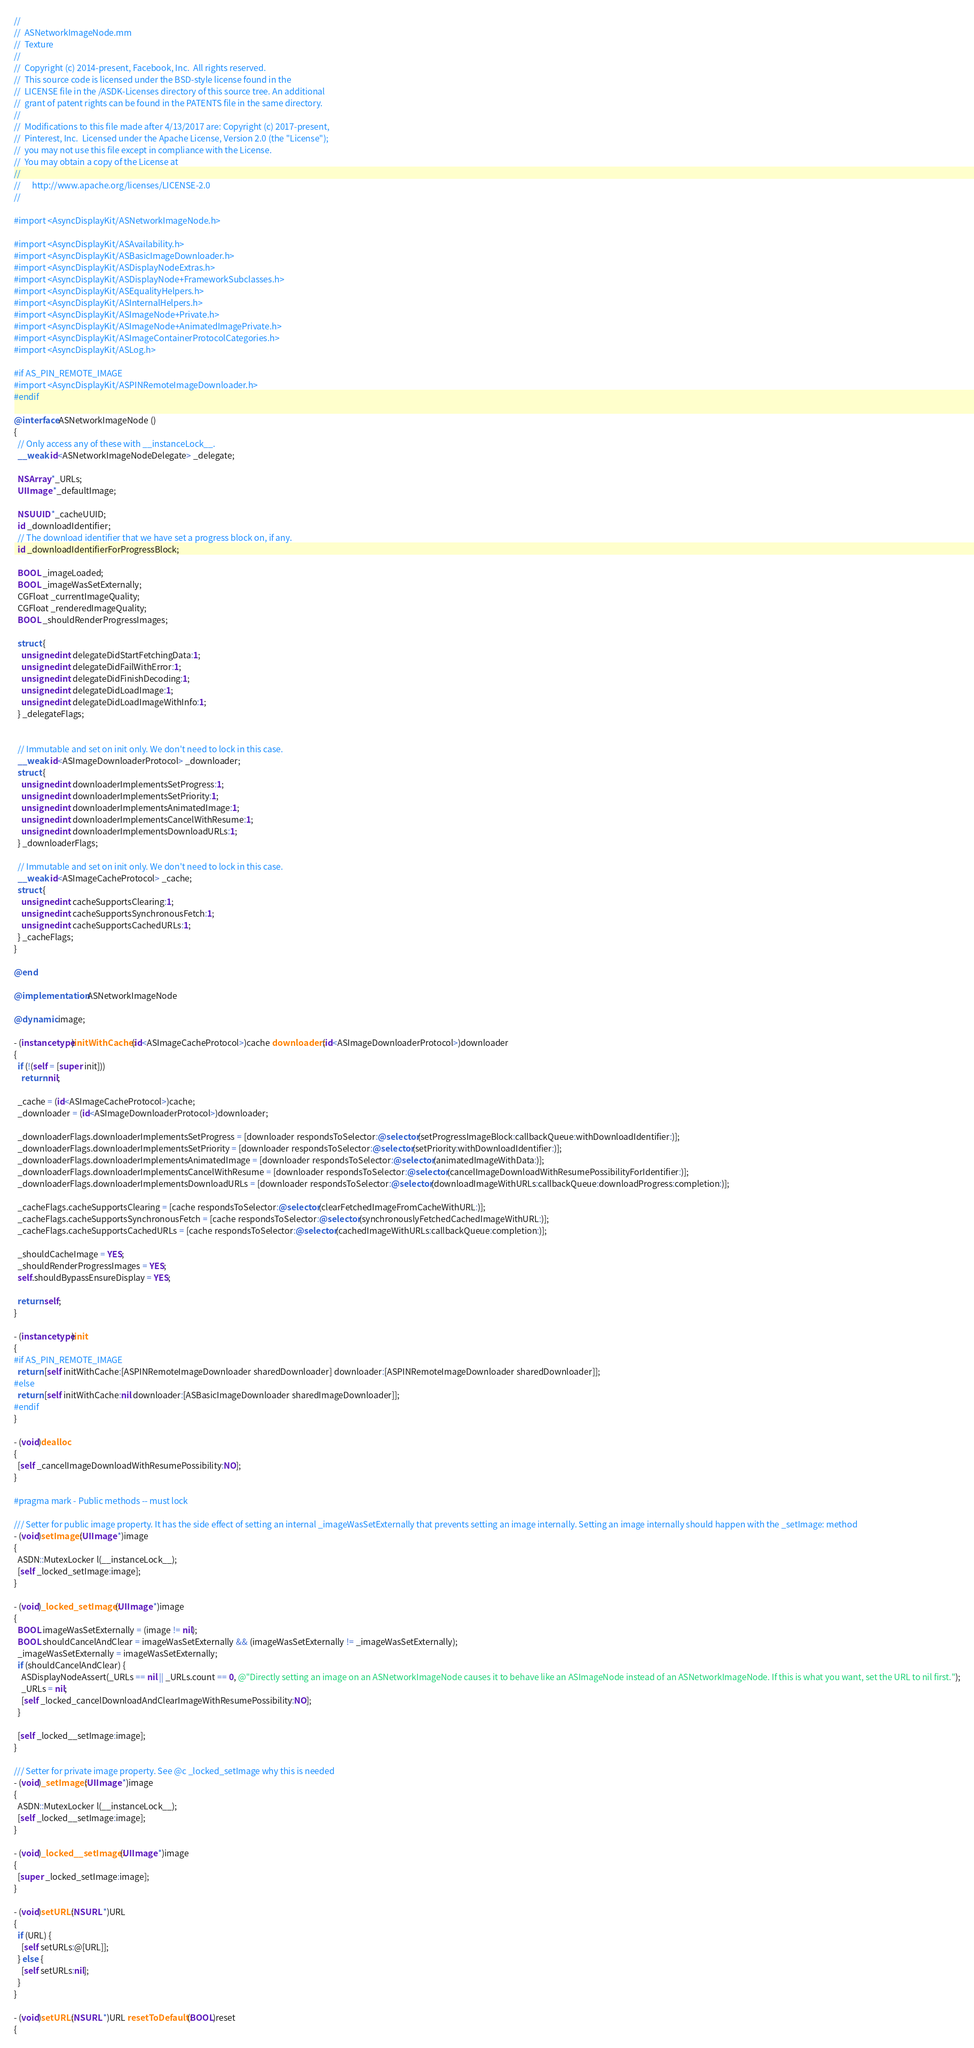Convert code to text. <code><loc_0><loc_0><loc_500><loc_500><_ObjectiveC_>//
//  ASNetworkImageNode.mm
//  Texture
//
//  Copyright (c) 2014-present, Facebook, Inc.  All rights reserved.
//  This source code is licensed under the BSD-style license found in the
//  LICENSE file in the /ASDK-Licenses directory of this source tree. An additional
//  grant of patent rights can be found in the PATENTS file in the same directory.
//
//  Modifications to this file made after 4/13/2017 are: Copyright (c) 2017-present,
//  Pinterest, Inc.  Licensed under the Apache License, Version 2.0 (the "License");
//  you may not use this file except in compliance with the License.
//  You may obtain a copy of the License at
//
//      http://www.apache.org/licenses/LICENSE-2.0
//

#import <AsyncDisplayKit/ASNetworkImageNode.h>

#import <AsyncDisplayKit/ASAvailability.h>
#import <AsyncDisplayKit/ASBasicImageDownloader.h>
#import <AsyncDisplayKit/ASDisplayNodeExtras.h>
#import <AsyncDisplayKit/ASDisplayNode+FrameworkSubclasses.h>
#import <AsyncDisplayKit/ASEqualityHelpers.h>
#import <AsyncDisplayKit/ASInternalHelpers.h>
#import <AsyncDisplayKit/ASImageNode+Private.h>
#import <AsyncDisplayKit/ASImageNode+AnimatedImagePrivate.h>
#import <AsyncDisplayKit/ASImageContainerProtocolCategories.h>
#import <AsyncDisplayKit/ASLog.h>

#if AS_PIN_REMOTE_IMAGE
#import <AsyncDisplayKit/ASPINRemoteImageDownloader.h>
#endif

@interface ASNetworkImageNode ()
{
  // Only access any of these with __instanceLock__.
  __weak id<ASNetworkImageNodeDelegate> _delegate;

  NSArray *_URLs;
  UIImage *_defaultImage;

  NSUUID *_cacheUUID;
  id _downloadIdentifier;
  // The download identifier that we have set a progress block on, if any.
  id _downloadIdentifierForProgressBlock;

  BOOL _imageLoaded;
  BOOL _imageWasSetExternally;
  CGFloat _currentImageQuality;
  CGFloat _renderedImageQuality;
  BOOL _shouldRenderProgressImages;

  struct {
    unsigned int delegateDidStartFetchingData:1;
    unsigned int delegateDidFailWithError:1;
    unsigned int delegateDidFinishDecoding:1;
    unsigned int delegateDidLoadImage:1;
    unsigned int delegateDidLoadImageWithInfo:1;
  } _delegateFlags;

  
  // Immutable and set on init only. We don't need to lock in this case.
  __weak id<ASImageDownloaderProtocol> _downloader;
  struct {
    unsigned int downloaderImplementsSetProgress:1;
    unsigned int downloaderImplementsSetPriority:1;
    unsigned int downloaderImplementsAnimatedImage:1;
    unsigned int downloaderImplementsCancelWithResume:1;
    unsigned int downloaderImplementsDownloadURLs:1;
  } _downloaderFlags;

  // Immutable and set on init only. We don't need to lock in this case.
  __weak id<ASImageCacheProtocol> _cache;
  struct {
    unsigned int cacheSupportsClearing:1;
    unsigned int cacheSupportsSynchronousFetch:1;
    unsigned int cacheSupportsCachedURLs:1;
  } _cacheFlags;
}

@end

@implementation ASNetworkImageNode

@dynamic image;

- (instancetype)initWithCache:(id<ASImageCacheProtocol>)cache downloader:(id<ASImageDownloaderProtocol>)downloader
{
  if (!(self = [super init]))
    return nil;

  _cache = (id<ASImageCacheProtocol>)cache;
  _downloader = (id<ASImageDownloaderProtocol>)downloader;
  
  _downloaderFlags.downloaderImplementsSetProgress = [downloader respondsToSelector:@selector(setProgressImageBlock:callbackQueue:withDownloadIdentifier:)];
  _downloaderFlags.downloaderImplementsSetPriority = [downloader respondsToSelector:@selector(setPriority:withDownloadIdentifier:)];
  _downloaderFlags.downloaderImplementsAnimatedImage = [downloader respondsToSelector:@selector(animatedImageWithData:)];
  _downloaderFlags.downloaderImplementsCancelWithResume = [downloader respondsToSelector:@selector(cancelImageDownloadWithResumePossibilityForIdentifier:)];
  _downloaderFlags.downloaderImplementsDownloadURLs = [downloader respondsToSelector:@selector(downloadImageWithURLs:callbackQueue:downloadProgress:completion:)];

  _cacheFlags.cacheSupportsClearing = [cache respondsToSelector:@selector(clearFetchedImageFromCacheWithURL:)];
  _cacheFlags.cacheSupportsSynchronousFetch = [cache respondsToSelector:@selector(synchronouslyFetchedCachedImageWithURL:)];
  _cacheFlags.cacheSupportsCachedURLs = [cache respondsToSelector:@selector(cachedImageWithURLs:callbackQueue:completion:)];
  
  _shouldCacheImage = YES;
  _shouldRenderProgressImages = YES;
  self.shouldBypassEnsureDisplay = YES;

  return self;
}

- (instancetype)init
{
#if AS_PIN_REMOTE_IMAGE
  return [self initWithCache:[ASPINRemoteImageDownloader sharedDownloader] downloader:[ASPINRemoteImageDownloader sharedDownloader]];
#else
  return [self initWithCache:nil downloader:[ASBasicImageDownloader sharedImageDownloader]];
#endif
}

- (void)dealloc
{
  [self _cancelImageDownloadWithResumePossibility:NO];
}

#pragma mark - Public methods -- must lock

/// Setter for public image property. It has the side effect of setting an internal _imageWasSetExternally that prevents setting an image internally. Setting an image internally should happen with the _setImage: method
- (void)setImage:(UIImage *)image
{
  ASDN::MutexLocker l(__instanceLock__);
  [self _locked_setImage:image];
}

- (void)_locked_setImage:(UIImage *)image
{
  BOOL imageWasSetExternally = (image != nil);
  BOOL shouldCancelAndClear = imageWasSetExternally && (imageWasSetExternally != _imageWasSetExternally);
  _imageWasSetExternally = imageWasSetExternally;
  if (shouldCancelAndClear) {
    ASDisplayNodeAssert(_URLs == nil || _URLs.count == 0, @"Directly setting an image on an ASNetworkImageNode causes it to behave like an ASImageNode instead of an ASNetworkImageNode. If this is what you want, set the URL to nil first.");
    _URLs = nil;
    [self _locked_cancelDownloadAndClearImageWithResumePossibility:NO];
  }
  
  [self _locked__setImage:image];
}

/// Setter for private image property. See @c _locked_setImage why this is needed
- (void)_setImage:(UIImage *)image
{
  ASDN::MutexLocker l(__instanceLock__);
  [self _locked__setImage:image];
}

- (void)_locked__setImage:(UIImage *)image
{
  [super _locked_setImage:image];
}

- (void)setURL:(NSURL *)URL
{
  if (URL) {
    [self setURLs:@[URL]];
  } else {
    [self setURLs:nil];
  }
}

- (void)setURL:(NSURL *)URL resetToDefault:(BOOL)reset
{</code> 